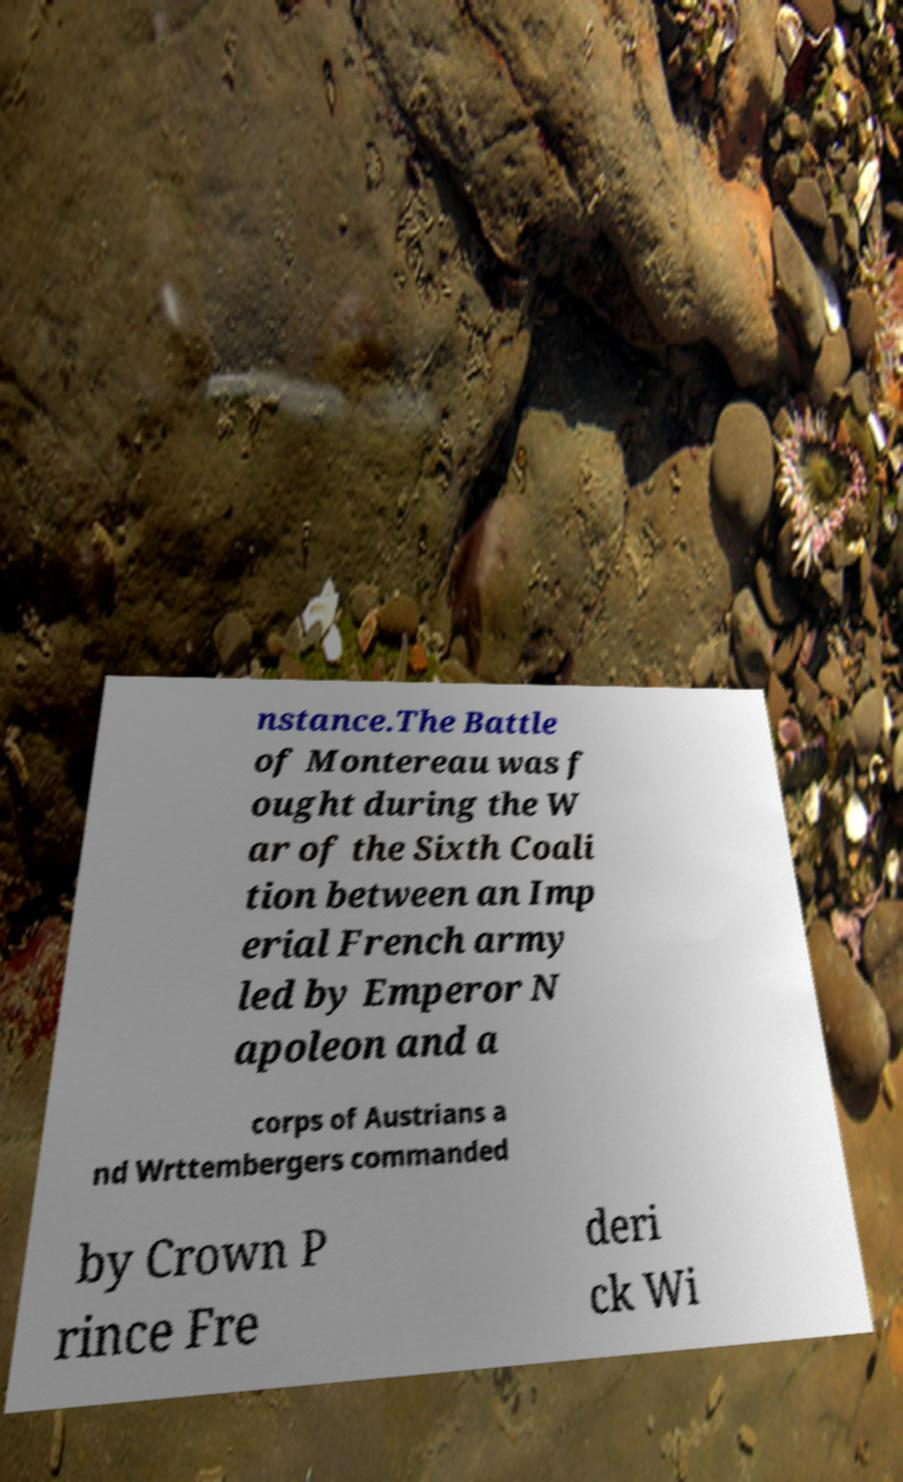For documentation purposes, I need the text within this image transcribed. Could you provide that? nstance.The Battle of Montereau was f ought during the W ar of the Sixth Coali tion between an Imp erial French army led by Emperor N apoleon and a corps of Austrians a nd Wrttembergers commanded by Crown P rince Fre deri ck Wi 